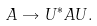Convert formula to latex. <formula><loc_0><loc_0><loc_500><loc_500>A \rightarrow U ^ { * } A U .</formula> 